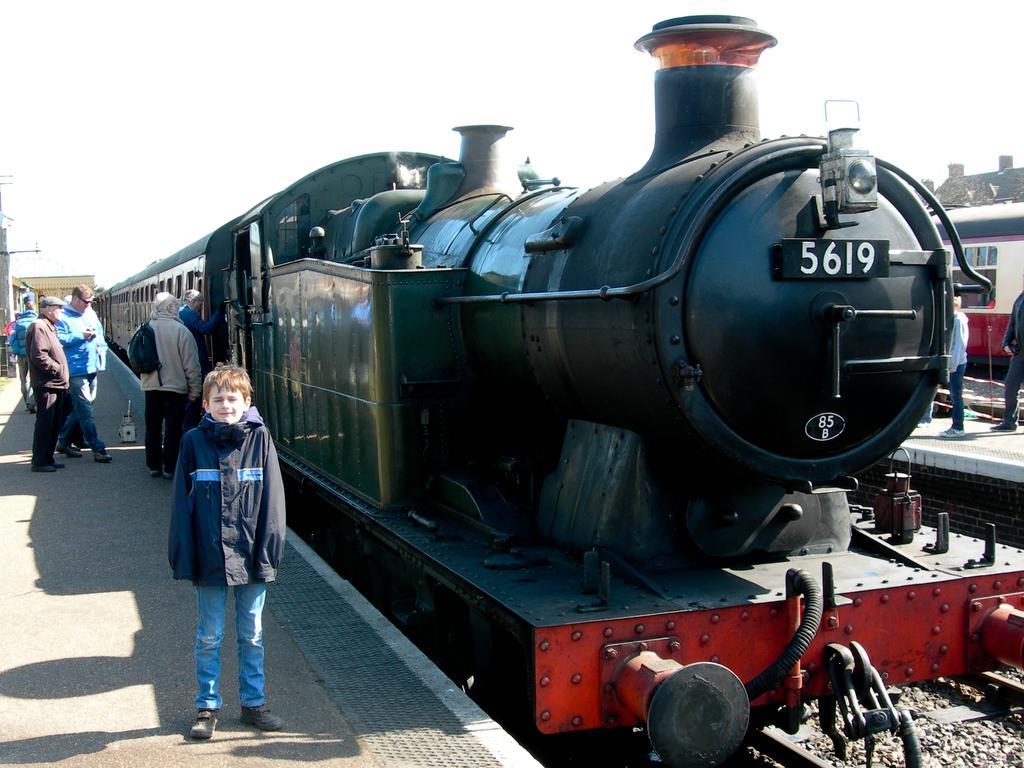Can you describe this image briefly? In this image, we can see two trains. Right side bottom, we can see a track. In the middle of the image, we can see few people are on the platforms. Few are standing and walking. Here a person wearing a backpack. Background we can see houses. Top of the image, there is a sky. Here we can see a boy is smiling. 